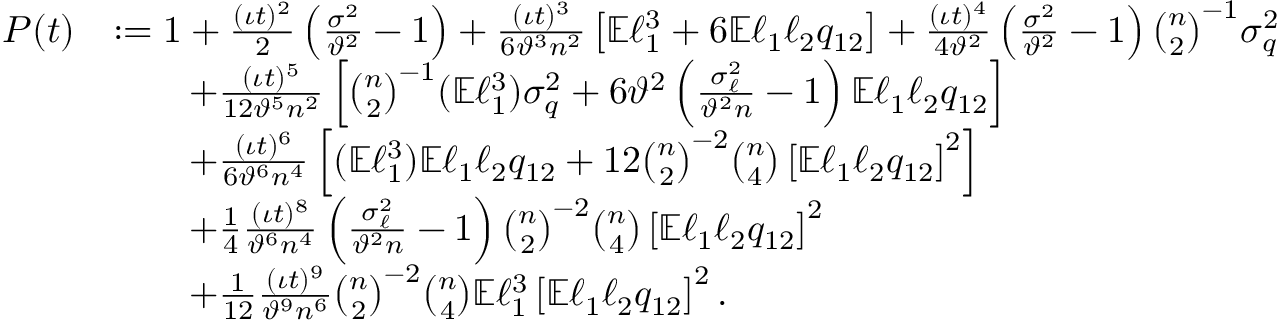<formula> <loc_0><loc_0><loc_500><loc_500>\begin{array} { r l } { P ( t ) } & { \colon = 1 + \frac { ( \iota t ) ^ { 2 } } { 2 } \left ( \frac { \sigma ^ { 2 } } { \vartheta ^ { 2 } } - 1 \right ) + \frac { ( \iota t ) ^ { 3 } } { 6 \vartheta ^ { 3 } n ^ { 2 } } \left [ \mathbb { E } \ell _ { 1 } ^ { 3 } + 6 \mathbb { E } \ell _ { 1 } \ell _ { 2 } q _ { 1 2 } \right ] + \frac { ( \iota t ) ^ { 4 } } { 4 \vartheta ^ { 2 } } \left ( \frac { \sigma ^ { 2 } } { \vartheta ^ { 2 } } - 1 \right ) \binom { n } { 2 } ^ { - 1 } \sigma _ { q } ^ { 2 } } \\ & { \quad + \frac { ( \iota t ) ^ { 5 } } { 1 2 \vartheta ^ { 5 } n ^ { 2 } } \left [ \binom { n } { 2 } ^ { - 1 } ( \mathbb { E } \ell _ { 1 } ^ { 3 } ) \sigma _ { q } ^ { 2 } + 6 \vartheta ^ { 2 } \left ( \frac { \sigma _ { \ell } ^ { 2 } } { \vartheta ^ { 2 } n } - 1 \right ) \mathbb { E } \ell _ { 1 } \ell _ { 2 } q _ { 1 2 } \right ] } \\ & { \quad + \frac { ( \iota t ) ^ { 6 } } { 6 \vartheta ^ { 6 } n ^ { 4 } } \left [ ( \mathbb { E } \ell _ { 1 } ^ { 3 } ) \mathbb { E } \ell _ { 1 } \ell _ { 2 } q _ { 1 2 } + 1 2 \binom { n } { 2 } ^ { - 2 } \binom { n } { 4 } \left [ \mathbb { E } \ell _ { 1 } \ell _ { 2 } q _ { 1 2 } \right ] ^ { 2 } \right ] } \\ & { \quad + \frac { 1 } { 4 } \frac { ( \iota t ) ^ { 8 } } { \vartheta ^ { 6 } n ^ { 4 } } \left ( \frac { \sigma _ { \ell } ^ { 2 } } { \vartheta ^ { 2 } n } - 1 \right ) \binom { n } { 2 } ^ { - 2 } \binom { n } { 4 } \left [ \mathbb { E } \ell _ { 1 } \ell _ { 2 } q _ { 1 2 } \right ] ^ { 2 } } \\ & { \quad + \frac { 1 } { 1 2 } \frac { ( \iota t ) ^ { 9 } } { \vartheta ^ { 9 } n ^ { 6 } } \binom { n } { 2 } ^ { - 2 } \binom { n } { 4 } \mathbb { E } \ell _ { 1 } ^ { 3 } \left [ \mathbb { E } \ell _ { 1 } \ell _ { 2 } q _ { 1 2 } \right ] ^ { 2 } . } \end{array}</formula> 